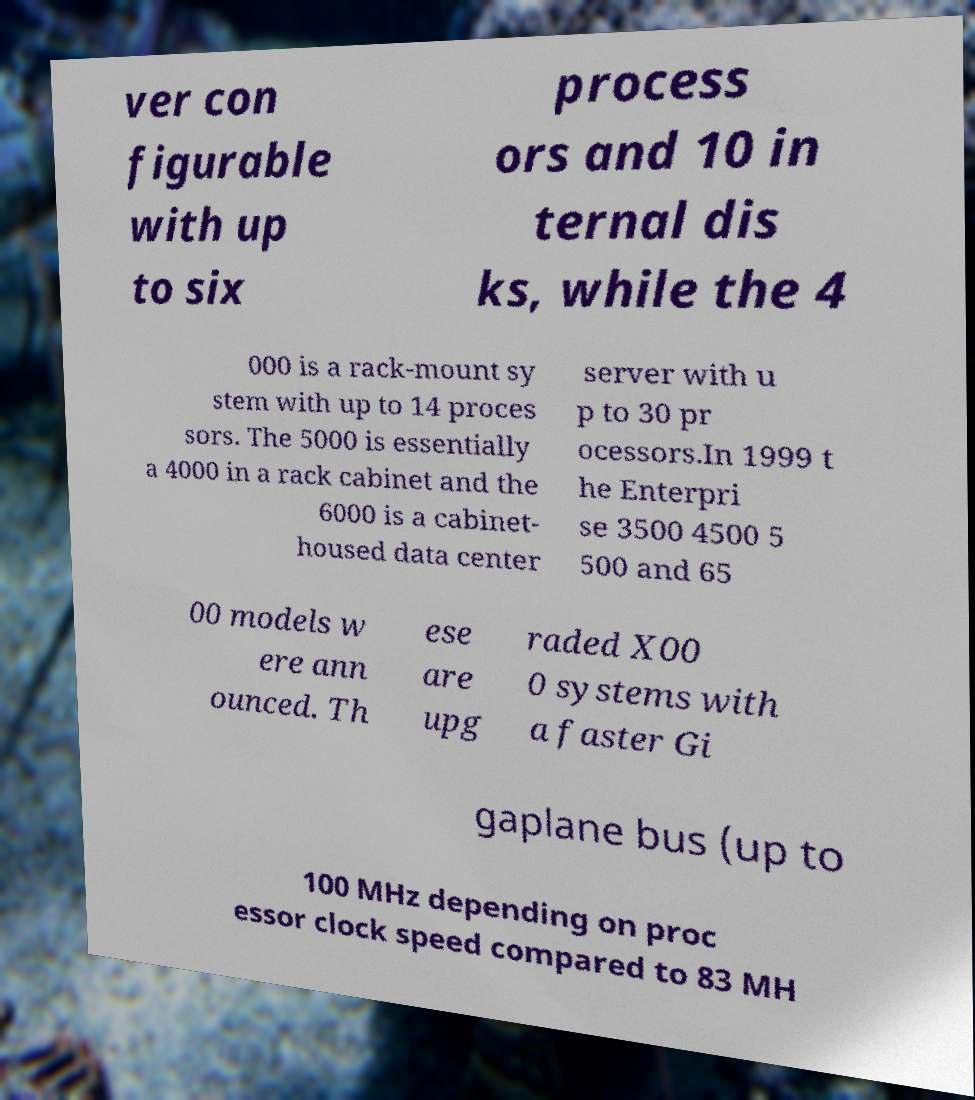Could you extract and type out the text from this image? ver con figurable with up to six process ors and 10 in ternal dis ks, while the 4 000 is a rack-mount sy stem with up to 14 proces sors. The 5000 is essentially a 4000 in a rack cabinet and the 6000 is a cabinet- housed data center server with u p to 30 pr ocessors.In 1999 t he Enterpri se 3500 4500 5 500 and 65 00 models w ere ann ounced. Th ese are upg raded X00 0 systems with a faster Gi gaplane bus (up to 100 MHz depending on proc essor clock speed compared to 83 MH 